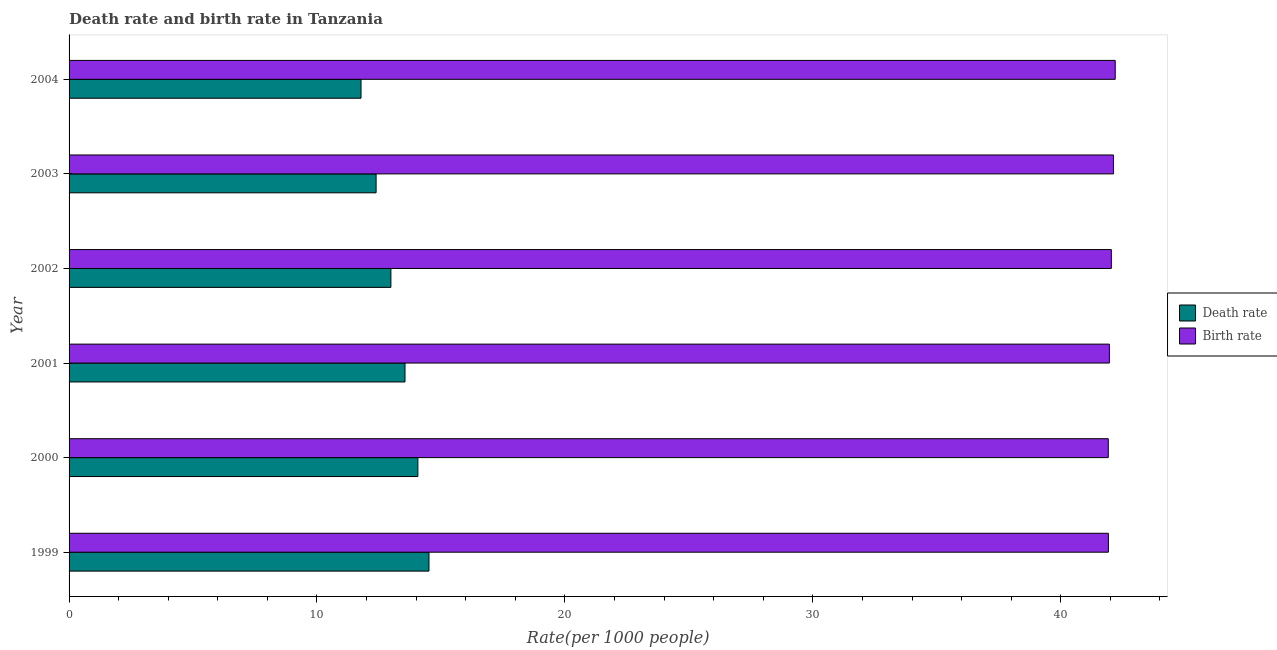Are the number of bars per tick equal to the number of legend labels?
Provide a succinct answer. Yes. How many bars are there on the 6th tick from the top?
Offer a very short reply. 2. What is the label of the 5th group of bars from the top?
Give a very brief answer. 2000. What is the birth rate in 2003?
Keep it short and to the point. 42.13. Across all years, what is the maximum birth rate?
Provide a succinct answer. 42.2. Across all years, what is the minimum death rate?
Your answer should be compact. 11.78. In which year was the death rate maximum?
Offer a very short reply. 1999. What is the total birth rate in the graph?
Your answer should be compact. 252.16. What is the difference between the birth rate in 2001 and that in 2002?
Give a very brief answer. -0.08. What is the difference between the birth rate in 2001 and the death rate in 2003?
Ensure brevity in your answer.  29.58. What is the average death rate per year?
Keep it short and to the point. 13.21. In the year 2003, what is the difference between the death rate and birth rate?
Make the answer very short. -29.74. In how many years, is the death rate greater than 4 ?
Provide a short and direct response. 6. What is the ratio of the death rate in 2000 to that in 2001?
Your answer should be compact. 1.04. Is the birth rate in 2000 less than that in 2001?
Provide a succinct answer. Yes. What is the difference between the highest and the second highest birth rate?
Give a very brief answer. 0.07. What is the difference between the highest and the lowest birth rate?
Provide a short and direct response. 0.28. Is the sum of the birth rate in 2002 and 2003 greater than the maximum death rate across all years?
Offer a terse response. Yes. What does the 1st bar from the top in 2001 represents?
Give a very brief answer. Birth rate. What does the 1st bar from the bottom in 2001 represents?
Offer a very short reply. Death rate. How many bars are there?
Your answer should be very brief. 12. What is the difference between two consecutive major ticks on the X-axis?
Ensure brevity in your answer.  10. Are the values on the major ticks of X-axis written in scientific E-notation?
Make the answer very short. No. Does the graph contain any zero values?
Your answer should be very brief. No. Does the graph contain grids?
Provide a succinct answer. No. What is the title of the graph?
Provide a succinct answer. Death rate and birth rate in Tanzania. What is the label or title of the X-axis?
Offer a very short reply. Rate(per 1000 people). What is the Rate(per 1000 people) in Death rate in 1999?
Offer a very short reply. 14.52. What is the Rate(per 1000 people) in Birth rate in 1999?
Your response must be concise. 41.92. What is the Rate(per 1000 people) of Death rate in 2000?
Your response must be concise. 14.07. What is the Rate(per 1000 people) in Birth rate in 2000?
Ensure brevity in your answer.  41.92. What is the Rate(per 1000 people) of Death rate in 2001?
Keep it short and to the point. 13.55. What is the Rate(per 1000 people) of Birth rate in 2001?
Your response must be concise. 41.96. What is the Rate(per 1000 people) of Death rate in 2002?
Give a very brief answer. 12.98. What is the Rate(per 1000 people) in Birth rate in 2002?
Your response must be concise. 42.04. What is the Rate(per 1000 people) of Death rate in 2003?
Ensure brevity in your answer.  12.38. What is the Rate(per 1000 people) of Birth rate in 2003?
Keep it short and to the point. 42.13. What is the Rate(per 1000 people) in Death rate in 2004?
Your response must be concise. 11.78. What is the Rate(per 1000 people) of Birth rate in 2004?
Offer a very short reply. 42.2. Across all years, what is the maximum Rate(per 1000 people) of Death rate?
Offer a terse response. 14.52. Across all years, what is the maximum Rate(per 1000 people) of Birth rate?
Offer a very short reply. 42.2. Across all years, what is the minimum Rate(per 1000 people) of Death rate?
Keep it short and to the point. 11.78. Across all years, what is the minimum Rate(per 1000 people) in Birth rate?
Give a very brief answer. 41.92. What is the total Rate(per 1000 people) in Death rate in the graph?
Offer a very short reply. 79.28. What is the total Rate(per 1000 people) of Birth rate in the graph?
Provide a short and direct response. 252.16. What is the difference between the Rate(per 1000 people) in Death rate in 1999 and that in 2000?
Offer a very short reply. 0.45. What is the difference between the Rate(per 1000 people) of Birth rate in 1999 and that in 2000?
Your answer should be compact. 0. What is the difference between the Rate(per 1000 people) in Death rate in 1999 and that in 2001?
Make the answer very short. 0.97. What is the difference between the Rate(per 1000 people) of Birth rate in 1999 and that in 2001?
Your answer should be compact. -0.04. What is the difference between the Rate(per 1000 people) of Death rate in 1999 and that in 2002?
Provide a short and direct response. 1.54. What is the difference between the Rate(per 1000 people) of Birth rate in 1999 and that in 2002?
Offer a terse response. -0.12. What is the difference between the Rate(per 1000 people) in Death rate in 1999 and that in 2003?
Your answer should be very brief. 2.13. What is the difference between the Rate(per 1000 people) of Birth rate in 1999 and that in 2003?
Keep it short and to the point. -0.2. What is the difference between the Rate(per 1000 people) in Death rate in 1999 and that in 2004?
Make the answer very short. 2.74. What is the difference between the Rate(per 1000 people) of Birth rate in 1999 and that in 2004?
Offer a very short reply. -0.28. What is the difference between the Rate(per 1000 people) of Death rate in 2000 and that in 2001?
Offer a very short reply. 0.52. What is the difference between the Rate(per 1000 people) of Birth rate in 2000 and that in 2001?
Keep it short and to the point. -0.04. What is the difference between the Rate(per 1000 people) of Death rate in 2000 and that in 2002?
Your answer should be very brief. 1.09. What is the difference between the Rate(per 1000 people) of Birth rate in 2000 and that in 2002?
Offer a very short reply. -0.12. What is the difference between the Rate(per 1000 people) of Death rate in 2000 and that in 2003?
Provide a succinct answer. 1.69. What is the difference between the Rate(per 1000 people) of Birth rate in 2000 and that in 2003?
Give a very brief answer. -0.21. What is the difference between the Rate(per 1000 people) of Death rate in 2000 and that in 2004?
Your response must be concise. 2.29. What is the difference between the Rate(per 1000 people) in Birth rate in 2000 and that in 2004?
Your answer should be very brief. -0.28. What is the difference between the Rate(per 1000 people) in Death rate in 2001 and that in 2002?
Offer a very short reply. 0.57. What is the difference between the Rate(per 1000 people) in Birth rate in 2001 and that in 2002?
Offer a very short reply. -0.08. What is the difference between the Rate(per 1000 people) of Death rate in 2001 and that in 2003?
Provide a succinct answer. 1.17. What is the difference between the Rate(per 1000 people) in Birth rate in 2001 and that in 2003?
Provide a short and direct response. -0.16. What is the difference between the Rate(per 1000 people) in Death rate in 2001 and that in 2004?
Ensure brevity in your answer.  1.77. What is the difference between the Rate(per 1000 people) in Birth rate in 2001 and that in 2004?
Give a very brief answer. -0.23. What is the difference between the Rate(per 1000 people) in Death rate in 2002 and that in 2003?
Give a very brief answer. 0.6. What is the difference between the Rate(per 1000 people) in Birth rate in 2002 and that in 2003?
Your response must be concise. -0.09. What is the difference between the Rate(per 1000 people) in Death rate in 2002 and that in 2004?
Provide a short and direct response. 1.21. What is the difference between the Rate(per 1000 people) in Birth rate in 2002 and that in 2004?
Ensure brevity in your answer.  -0.16. What is the difference between the Rate(per 1000 people) in Death rate in 2003 and that in 2004?
Provide a short and direct response. 0.61. What is the difference between the Rate(per 1000 people) in Birth rate in 2003 and that in 2004?
Your answer should be compact. -0.07. What is the difference between the Rate(per 1000 people) in Death rate in 1999 and the Rate(per 1000 people) in Birth rate in 2000?
Your response must be concise. -27.4. What is the difference between the Rate(per 1000 people) of Death rate in 1999 and the Rate(per 1000 people) of Birth rate in 2001?
Ensure brevity in your answer.  -27.45. What is the difference between the Rate(per 1000 people) in Death rate in 1999 and the Rate(per 1000 people) in Birth rate in 2002?
Your answer should be compact. -27.52. What is the difference between the Rate(per 1000 people) of Death rate in 1999 and the Rate(per 1000 people) of Birth rate in 2003?
Keep it short and to the point. -27.61. What is the difference between the Rate(per 1000 people) of Death rate in 1999 and the Rate(per 1000 people) of Birth rate in 2004?
Offer a terse response. -27.68. What is the difference between the Rate(per 1000 people) in Death rate in 2000 and the Rate(per 1000 people) in Birth rate in 2001?
Keep it short and to the point. -27.89. What is the difference between the Rate(per 1000 people) of Death rate in 2000 and the Rate(per 1000 people) of Birth rate in 2002?
Your answer should be compact. -27.97. What is the difference between the Rate(per 1000 people) in Death rate in 2000 and the Rate(per 1000 people) in Birth rate in 2003?
Your answer should be compact. -28.06. What is the difference between the Rate(per 1000 people) in Death rate in 2000 and the Rate(per 1000 people) in Birth rate in 2004?
Offer a very short reply. -28.13. What is the difference between the Rate(per 1000 people) of Death rate in 2001 and the Rate(per 1000 people) of Birth rate in 2002?
Provide a short and direct response. -28.49. What is the difference between the Rate(per 1000 people) of Death rate in 2001 and the Rate(per 1000 people) of Birth rate in 2003?
Make the answer very short. -28.58. What is the difference between the Rate(per 1000 people) of Death rate in 2001 and the Rate(per 1000 people) of Birth rate in 2004?
Your answer should be very brief. -28.65. What is the difference between the Rate(per 1000 people) in Death rate in 2002 and the Rate(per 1000 people) in Birth rate in 2003?
Provide a succinct answer. -29.14. What is the difference between the Rate(per 1000 people) of Death rate in 2002 and the Rate(per 1000 people) of Birth rate in 2004?
Your answer should be compact. -29.22. What is the difference between the Rate(per 1000 people) in Death rate in 2003 and the Rate(per 1000 people) in Birth rate in 2004?
Ensure brevity in your answer.  -29.81. What is the average Rate(per 1000 people) of Death rate per year?
Offer a terse response. 13.21. What is the average Rate(per 1000 people) of Birth rate per year?
Offer a very short reply. 42.03. In the year 1999, what is the difference between the Rate(per 1000 people) in Death rate and Rate(per 1000 people) in Birth rate?
Provide a succinct answer. -27.4. In the year 2000, what is the difference between the Rate(per 1000 people) in Death rate and Rate(per 1000 people) in Birth rate?
Your response must be concise. -27.85. In the year 2001, what is the difference between the Rate(per 1000 people) in Death rate and Rate(per 1000 people) in Birth rate?
Provide a succinct answer. -28.41. In the year 2002, what is the difference between the Rate(per 1000 people) of Death rate and Rate(per 1000 people) of Birth rate?
Ensure brevity in your answer.  -29.06. In the year 2003, what is the difference between the Rate(per 1000 people) of Death rate and Rate(per 1000 people) of Birth rate?
Your answer should be very brief. -29.74. In the year 2004, what is the difference between the Rate(per 1000 people) of Death rate and Rate(per 1000 people) of Birth rate?
Provide a short and direct response. -30.42. What is the ratio of the Rate(per 1000 people) of Death rate in 1999 to that in 2000?
Your answer should be very brief. 1.03. What is the ratio of the Rate(per 1000 people) of Birth rate in 1999 to that in 2000?
Offer a very short reply. 1. What is the ratio of the Rate(per 1000 people) in Death rate in 1999 to that in 2001?
Your response must be concise. 1.07. What is the ratio of the Rate(per 1000 people) of Death rate in 1999 to that in 2002?
Make the answer very short. 1.12. What is the ratio of the Rate(per 1000 people) in Death rate in 1999 to that in 2003?
Your answer should be very brief. 1.17. What is the ratio of the Rate(per 1000 people) of Birth rate in 1999 to that in 2003?
Offer a terse response. 1. What is the ratio of the Rate(per 1000 people) in Death rate in 1999 to that in 2004?
Give a very brief answer. 1.23. What is the ratio of the Rate(per 1000 people) of Birth rate in 1999 to that in 2004?
Give a very brief answer. 0.99. What is the ratio of the Rate(per 1000 people) in Death rate in 2000 to that in 2001?
Provide a succinct answer. 1.04. What is the ratio of the Rate(per 1000 people) in Death rate in 2000 to that in 2002?
Your answer should be compact. 1.08. What is the ratio of the Rate(per 1000 people) of Death rate in 2000 to that in 2003?
Make the answer very short. 1.14. What is the ratio of the Rate(per 1000 people) of Death rate in 2000 to that in 2004?
Offer a terse response. 1.19. What is the ratio of the Rate(per 1000 people) of Birth rate in 2000 to that in 2004?
Your answer should be very brief. 0.99. What is the ratio of the Rate(per 1000 people) in Death rate in 2001 to that in 2002?
Your response must be concise. 1.04. What is the ratio of the Rate(per 1000 people) in Death rate in 2001 to that in 2003?
Offer a very short reply. 1.09. What is the ratio of the Rate(per 1000 people) of Birth rate in 2001 to that in 2003?
Your response must be concise. 1. What is the ratio of the Rate(per 1000 people) in Death rate in 2001 to that in 2004?
Offer a terse response. 1.15. What is the ratio of the Rate(per 1000 people) of Death rate in 2002 to that in 2003?
Ensure brevity in your answer.  1.05. What is the ratio of the Rate(per 1000 people) in Death rate in 2002 to that in 2004?
Your answer should be compact. 1.1. What is the ratio of the Rate(per 1000 people) in Birth rate in 2002 to that in 2004?
Give a very brief answer. 1. What is the ratio of the Rate(per 1000 people) in Death rate in 2003 to that in 2004?
Ensure brevity in your answer.  1.05. What is the ratio of the Rate(per 1000 people) of Birth rate in 2003 to that in 2004?
Your answer should be very brief. 1. What is the difference between the highest and the second highest Rate(per 1000 people) in Death rate?
Make the answer very short. 0.45. What is the difference between the highest and the second highest Rate(per 1000 people) in Birth rate?
Make the answer very short. 0.07. What is the difference between the highest and the lowest Rate(per 1000 people) of Death rate?
Offer a very short reply. 2.74. What is the difference between the highest and the lowest Rate(per 1000 people) in Birth rate?
Provide a succinct answer. 0.28. 